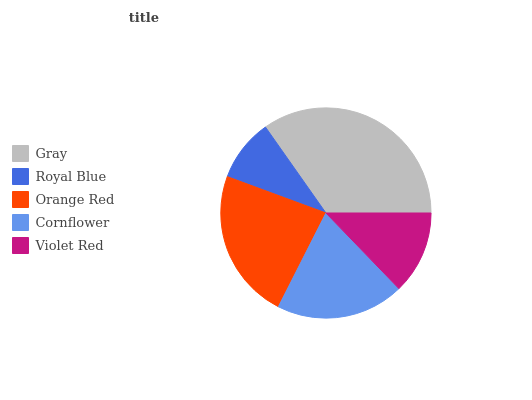Is Royal Blue the minimum?
Answer yes or no. Yes. Is Gray the maximum?
Answer yes or no. Yes. Is Orange Red the minimum?
Answer yes or no. No. Is Orange Red the maximum?
Answer yes or no. No. Is Orange Red greater than Royal Blue?
Answer yes or no. Yes. Is Royal Blue less than Orange Red?
Answer yes or no. Yes. Is Royal Blue greater than Orange Red?
Answer yes or no. No. Is Orange Red less than Royal Blue?
Answer yes or no. No. Is Cornflower the high median?
Answer yes or no. Yes. Is Cornflower the low median?
Answer yes or no. Yes. Is Violet Red the high median?
Answer yes or no. No. Is Gray the low median?
Answer yes or no. No. 